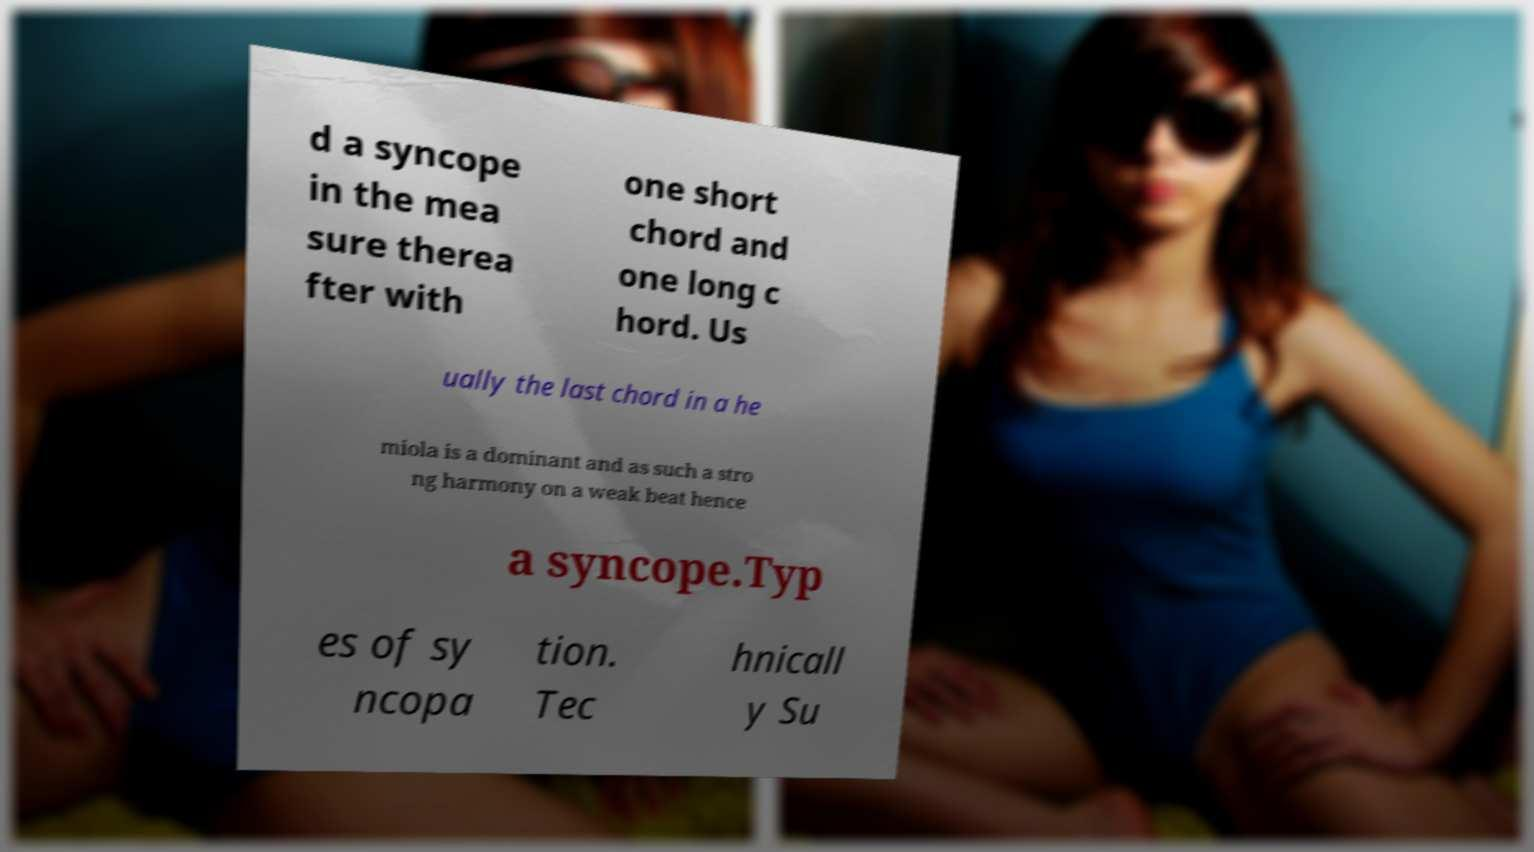What messages or text are displayed in this image? I need them in a readable, typed format. d a syncope in the mea sure therea fter with one short chord and one long c hord. Us ually the last chord in a he miola is a dominant and as such a stro ng harmony on a weak beat hence a syncope.Typ es of sy ncopa tion. Tec hnicall y Su 